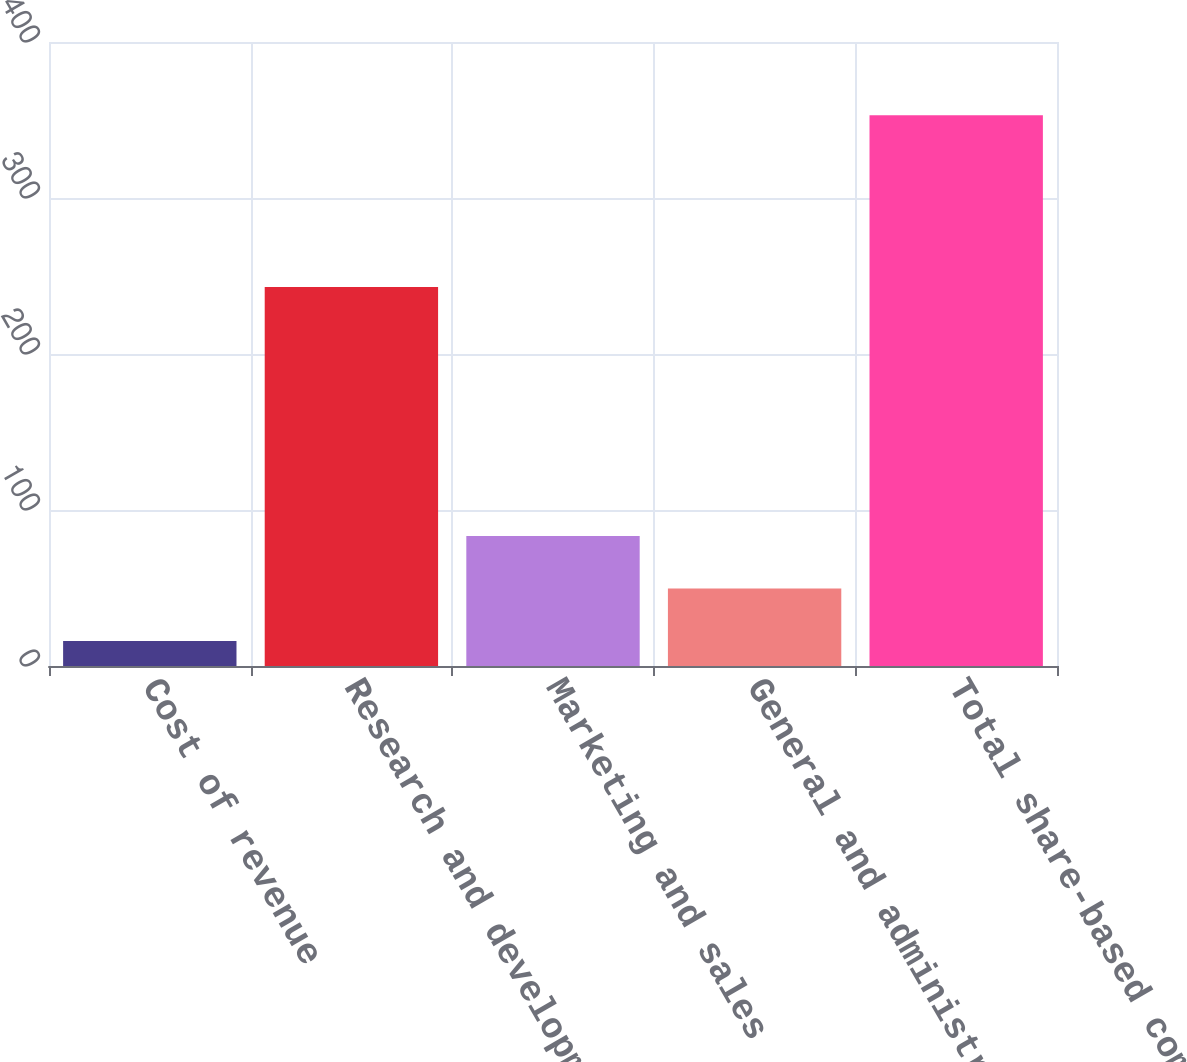Convert chart. <chart><loc_0><loc_0><loc_500><loc_500><bar_chart><fcel>Cost of revenue<fcel>Research and development<fcel>Marketing and sales<fcel>General and administrative<fcel>Total share-based compensation<nl><fcel>16<fcel>243<fcel>83.4<fcel>49.7<fcel>353<nl></chart> 